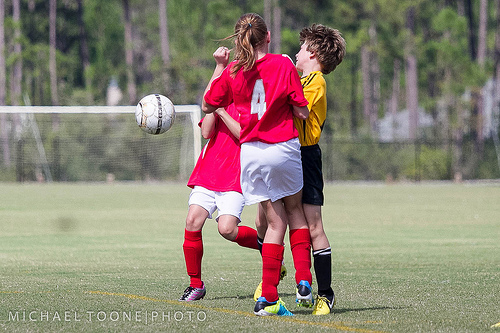<image>
Is the boy next to the ball? Yes. The boy is positioned adjacent to the ball, located nearby in the same general area. 